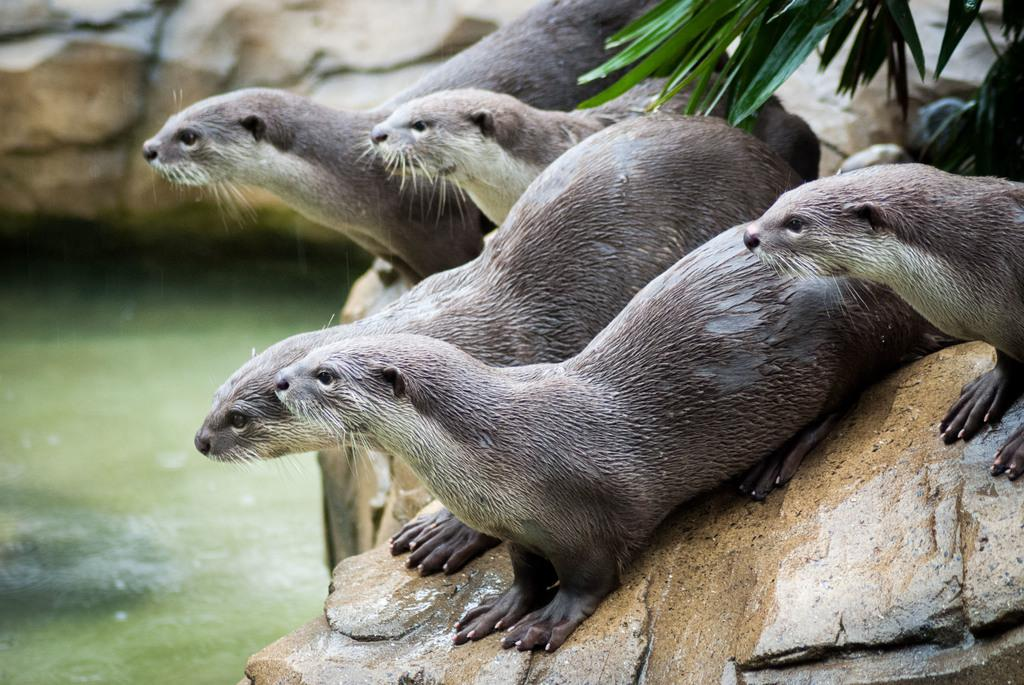What type of animals can be seen on the right side of the image? There are seals on the right side of the image. What body of water is visible at the bottom of the image? There is a river at the bottom of the image. What type of natural feature can be seen in the background of the image? There are rocks in the background of the image. What type of vegetation is visible at the top of the image? There is a plant at the top of the image. What type of apparel is the seal wearing in the image? There is no apparel visible on the seals in the image. How much milk can be seen in the image? There is no milk present in the image. 